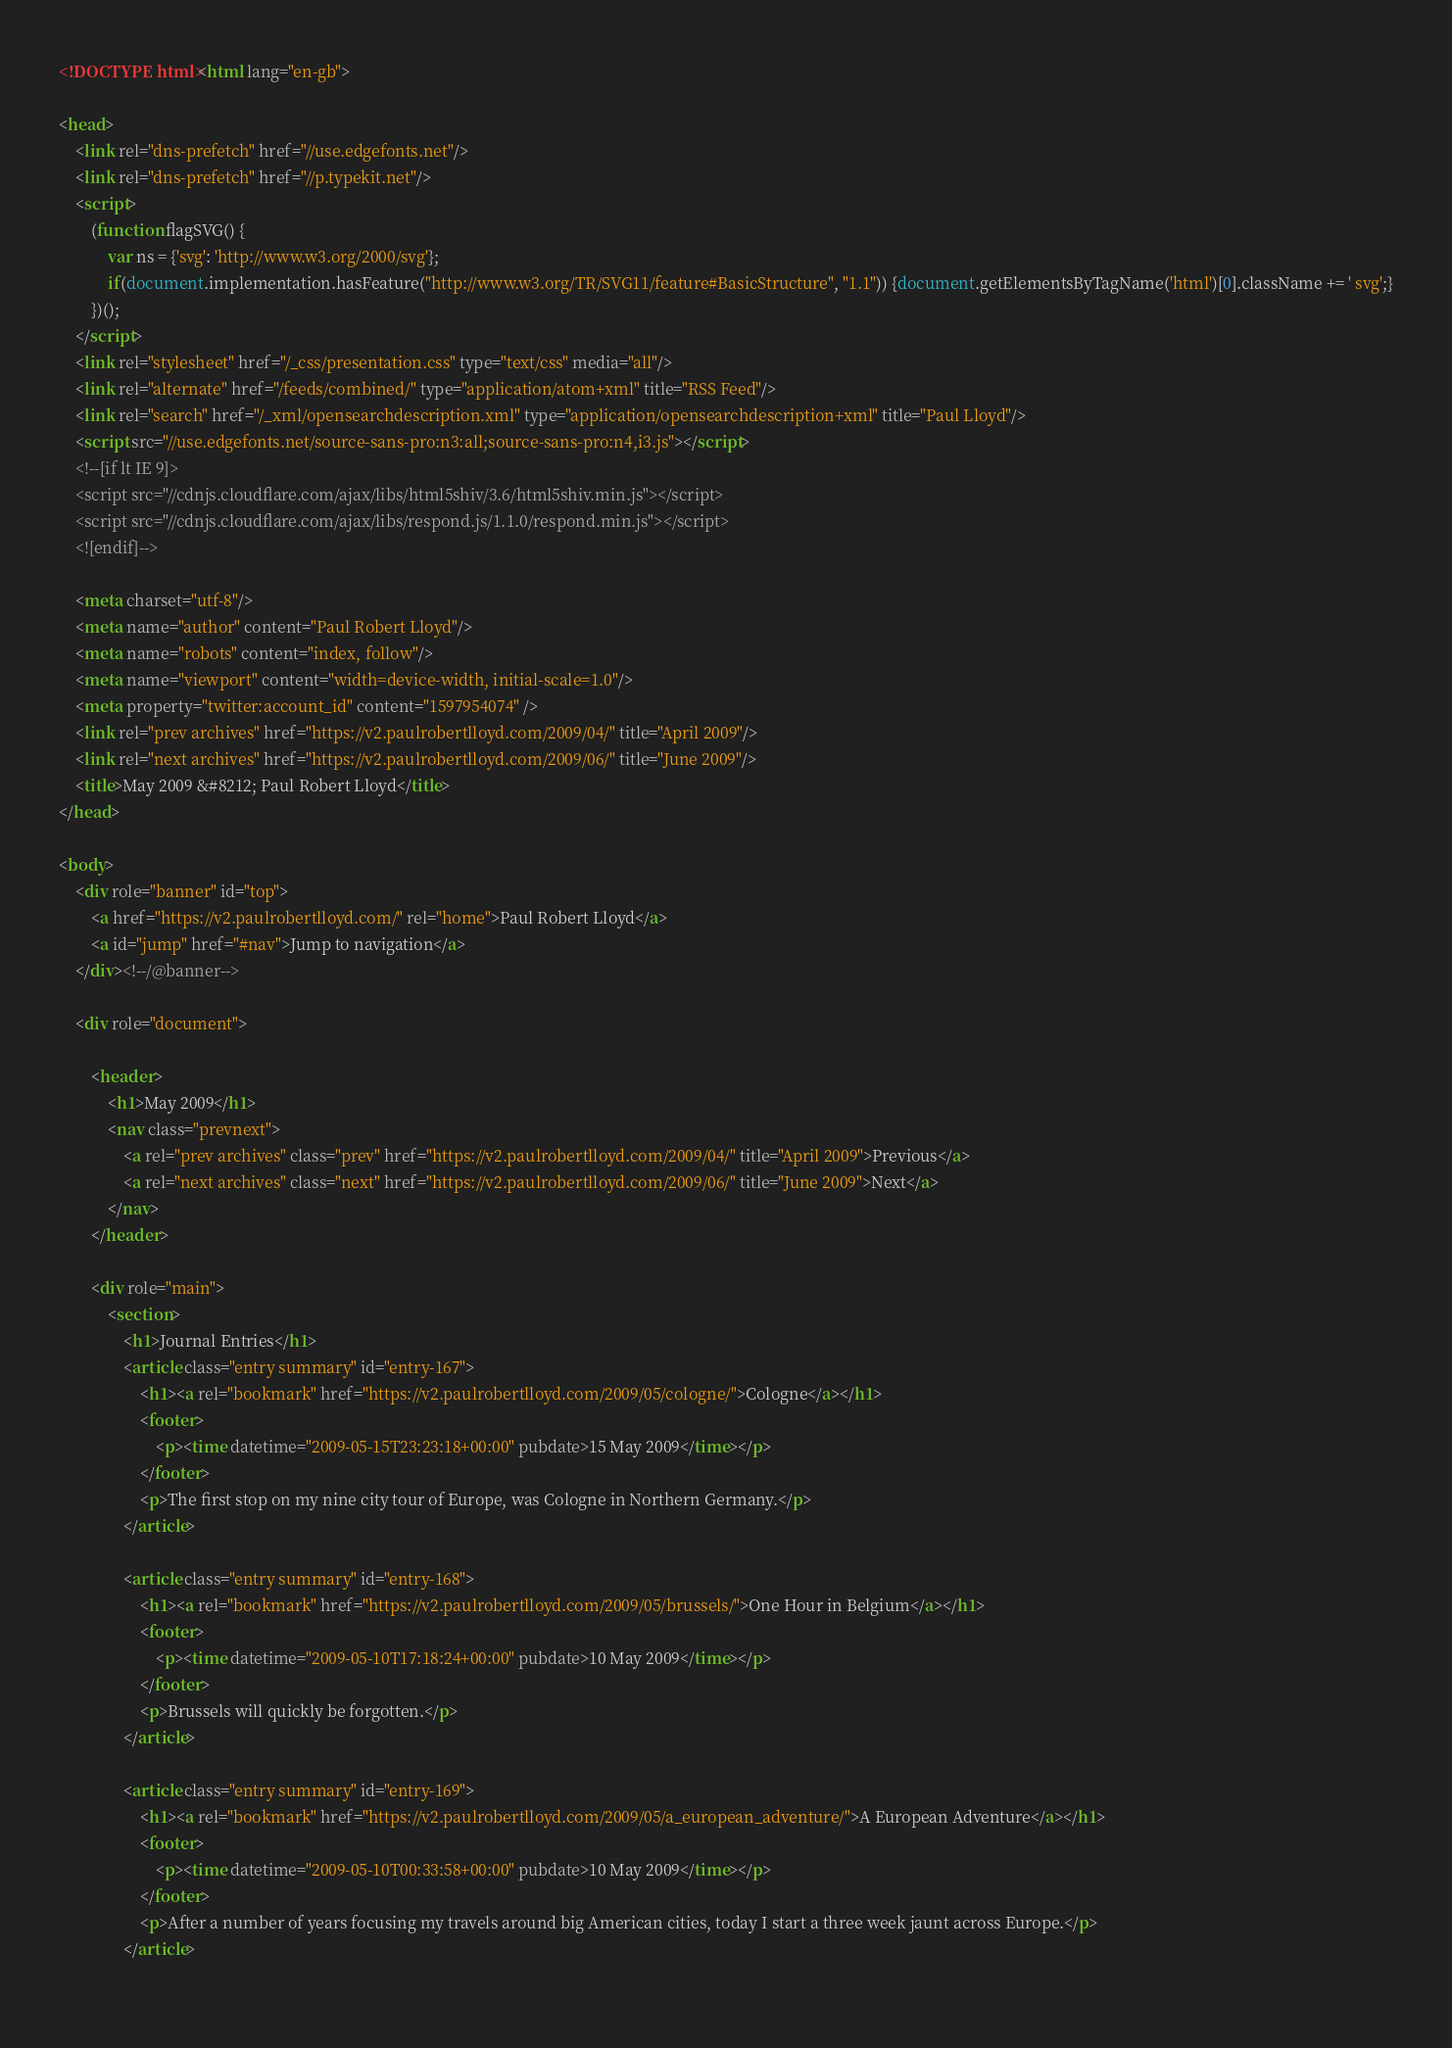Convert code to text. <code><loc_0><loc_0><loc_500><loc_500><_HTML_><!DOCTYPE html><html lang="en-gb">

<head>
    <link rel="dns-prefetch" href="//use.edgefonts.net"/>
    <link rel="dns-prefetch" href="//p.typekit.net"/>
    <script>
        (function flagSVG() {
            var ns = {'svg': 'http://www.w3.org/2000/svg'};
            if(document.implementation.hasFeature("http://www.w3.org/TR/SVG11/feature#BasicStructure", "1.1")) {document.getElementsByTagName('html')[0].className += ' svg';}
        })();
    </script>
    <link rel="stylesheet" href="/_css/presentation.css" type="text/css" media="all"/>
    <link rel="alternate" href="/feeds/combined/" type="application/atom+xml" title="RSS Feed"/>
    <link rel="search" href="/_xml/opensearchdescription.xml" type="application/opensearchdescription+xml" title="Paul Lloyd"/>
    <script src="//use.edgefonts.net/source-sans-pro:n3:all;source-sans-pro:n4,i3.js"></script>
    <!--[if lt IE 9]>
    <script src="//cdnjs.cloudflare.com/ajax/libs/html5shiv/3.6/html5shiv.min.js"></script>
    <script src="//cdnjs.cloudflare.com/ajax/libs/respond.js/1.1.0/respond.min.js"></script>
    <![endif]-->

    <meta charset="utf-8"/>
    <meta name="author" content="Paul Robert Lloyd"/>
    <meta name="robots" content="index, follow"/>
    <meta name="viewport" content="width=device-width, initial-scale=1.0"/>
    <meta property="twitter:account_id" content="1597954074" />
    <link rel="prev archives" href="https://v2.paulrobertlloyd.com/2009/04/" title="April 2009"/>
    <link rel="next archives" href="https://v2.paulrobertlloyd.com/2009/06/" title="June 2009"/>
    <title>May 2009 &#8212; Paul Robert Lloyd</title>
</head>

<body>
    <div role="banner" id="top">
        <a href="https://v2.paulrobertlloyd.com/" rel="home">Paul Robert Lloyd</a>
        <a id="jump" href="#nav">Jump to navigation</a>
    </div><!--/@banner-->

    <div role="document">

        <header>
            <h1>May 2009</h1>
            <nav class="prevnext">
                <a rel="prev archives" class="prev" href="https://v2.paulrobertlloyd.com/2009/04/" title="April 2009">Previous</a>
                <a rel="next archives" class="next" href="https://v2.paulrobertlloyd.com/2009/06/" title="June 2009">Next</a>
            </nav>
        </header>

        <div role="main">
            <section>
                <h1>Journal Entries</h1>
                <article class="entry summary" id="entry-167">
                    <h1><a rel="bookmark" href="https://v2.paulrobertlloyd.com/2009/05/cologne/">Cologne</a></h1>
                    <footer>
                        <p><time datetime="2009-05-15T23:23:18+00:00" pubdate>15 May 2009</time></p>
                    </footer>
                    <p>The first stop on my nine city tour of Europe, was Cologne in Northern Germany.</p>
                </article>
                
                <article class="entry summary" id="entry-168">
                    <h1><a rel="bookmark" href="https://v2.paulrobertlloyd.com/2009/05/brussels/">One Hour in Belgium</a></h1>
                    <footer>
                        <p><time datetime="2009-05-10T17:18:24+00:00" pubdate>10 May 2009</time></p>
                    </footer>
                    <p>Brussels will quickly be forgotten.</p>
                </article>
                
                <article class="entry summary" id="entry-169">
                    <h1><a rel="bookmark" href="https://v2.paulrobertlloyd.com/2009/05/a_european_adventure/">A European Adventure</a></h1>
                    <footer>
                        <p><time datetime="2009-05-10T00:33:58+00:00" pubdate>10 May 2009</time></p>
                    </footer>
                    <p>After a number of years focusing my travels around big American cities, today I start a three week jaunt across Europe.</p>
                </article>
                </code> 